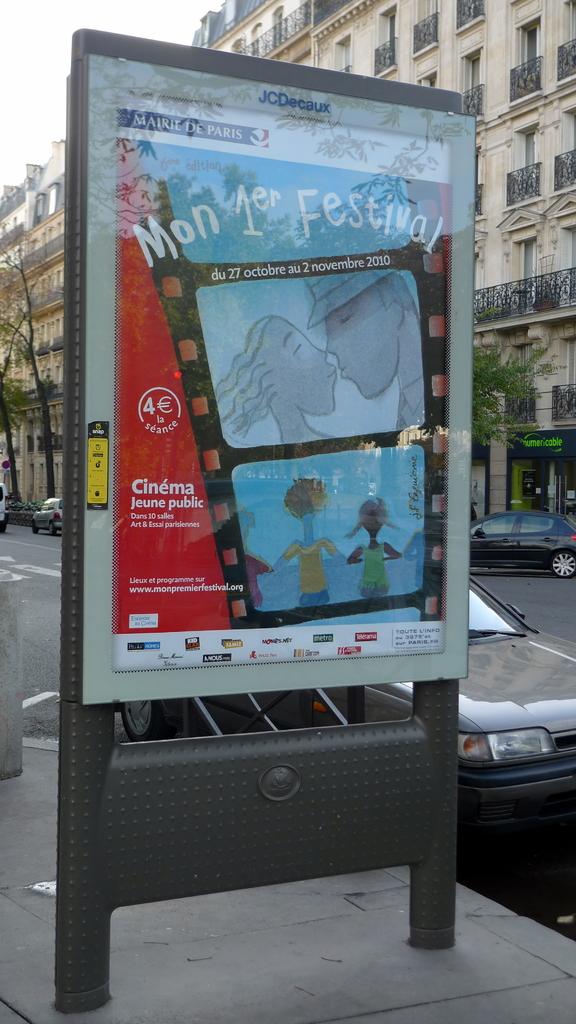What is the name of the city up top?
Give a very brief answer. Paris. 